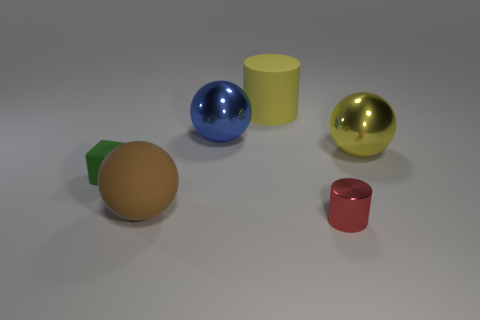Can you explain the lighting and shadows in the scene? Certainly. The scene is uniformly lit from above, casting soft, diffuse shadows directly beneath each object, which indicates an ambient light source, possibly resembling an overcast sky or soft-box lighting in a photography studio. The shadows are soft-edged and subtle, without harsh lines, further affirming the diffuse nature of the light. This kind of lighting helps to bring out the form of the objects without creating distracting shadows. 